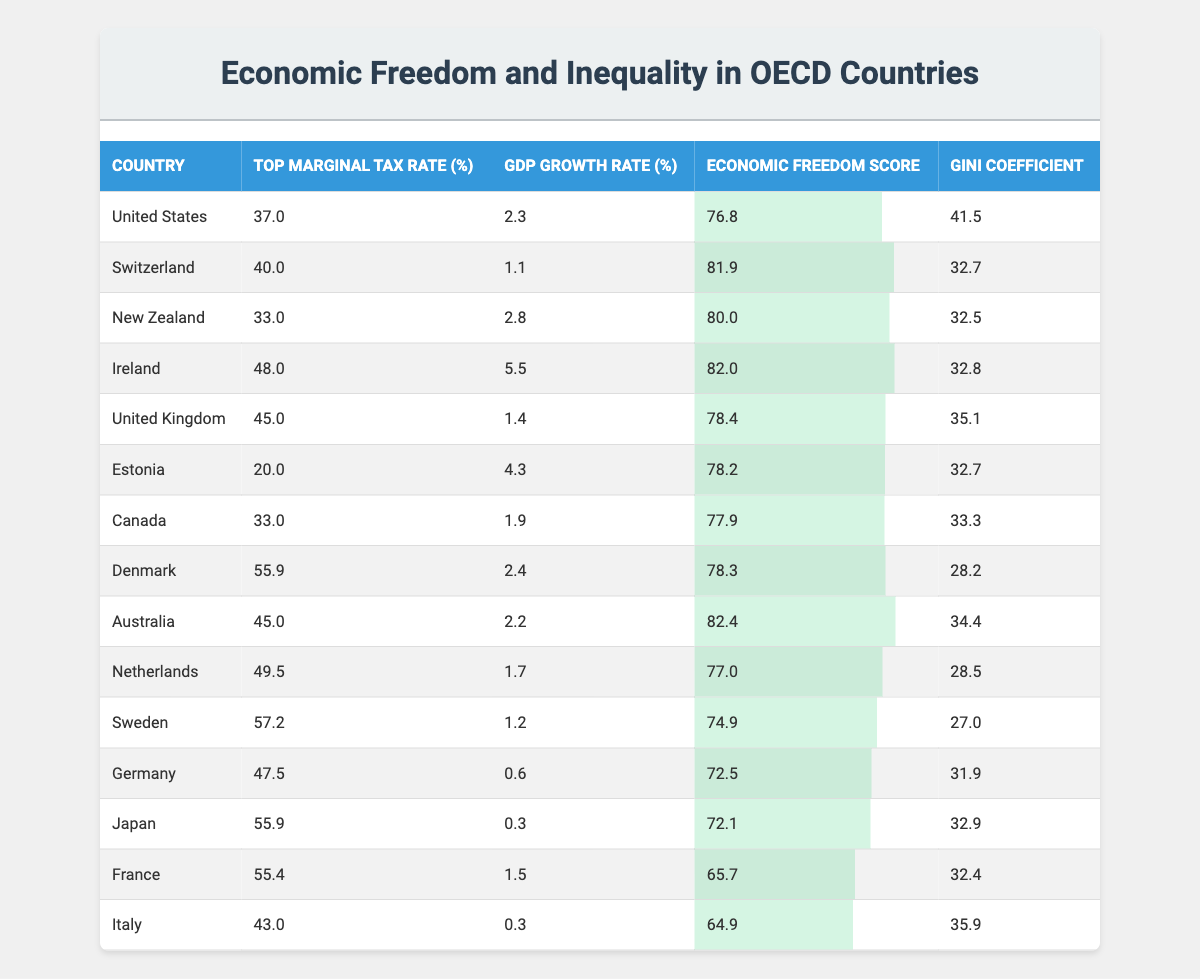What is the top marginal tax rate in Japan? The table lists the top marginal tax rate for Japan as 55.9%.
Answer: 55.9% Which country has the highest GDP growth rate? The GDP growth rates are compared in the table, and Ireland has the highest GDP growth rate at 5.5%.
Answer: Ireland What is the economic freedom score of the United States? The United States has an economic freedom score of 76.8, as shown in the table.
Answer: 76.8 Which country has the lowest Gini coefficient? From the table, Switzerland has the lowest Gini coefficient at 32.7.
Answer: 32.7 Is it true that more than half of the countries listed have a top marginal tax rate above 45%? Counting the countries in the table with tax rates above 45% (Ireland, United Kingdom, Netherlands, Sweden, France, and Japan), we see there are 6 out of 15 countries, which is more than half.
Answer: Yes What is the average top marginal tax rate for the countries listed in the table? To calculate the average, sum the top marginal tax rates of all countries, which is 37 + 40 + 33 + 48 + 45 + 20 + 33 + 55.9 + 45 + 49.5 + 57.2 + 47.5 + 55.9 + 55.4 + 43 =  702.5. There are 15 countries, so the average is 702.5 / 15 = 46.83.
Answer: 46.83 Which country has both a high economic freedom score and a high GDP growth rate? By examining the data, Ireland has a high economic freedom score of 82.0 and the highest GDP growth rate of 5.5%.
Answer: Ireland Do countries with lower Gini coefficients tend to have higher GDP growth rates? A review of the table shows that countries with lower Gini coefficients like Switzerland (32.7) and Estonia (32.7) do not have high GDP growth rates, compared to Ireland (48.0 Gini, 5.5 GDP growth). This suggests a negative correlation.
Answer: No What is the difference in GDP growth rate between Denmark and Canada? Denmark's GDP growth rate is 2.4%, and Canada's is 1.9%. The difference is 2.4 - 1.9 = 0.5%.
Answer: 0.5% Which country has a top marginal tax rate that is closest to the average? The average top marginal tax rate calculated earlier is 46.83. The countries closest to this value are Netherlands at 49.5, which is only a difference of 2.67, indicating it's the nearest.
Answer: Netherlands 